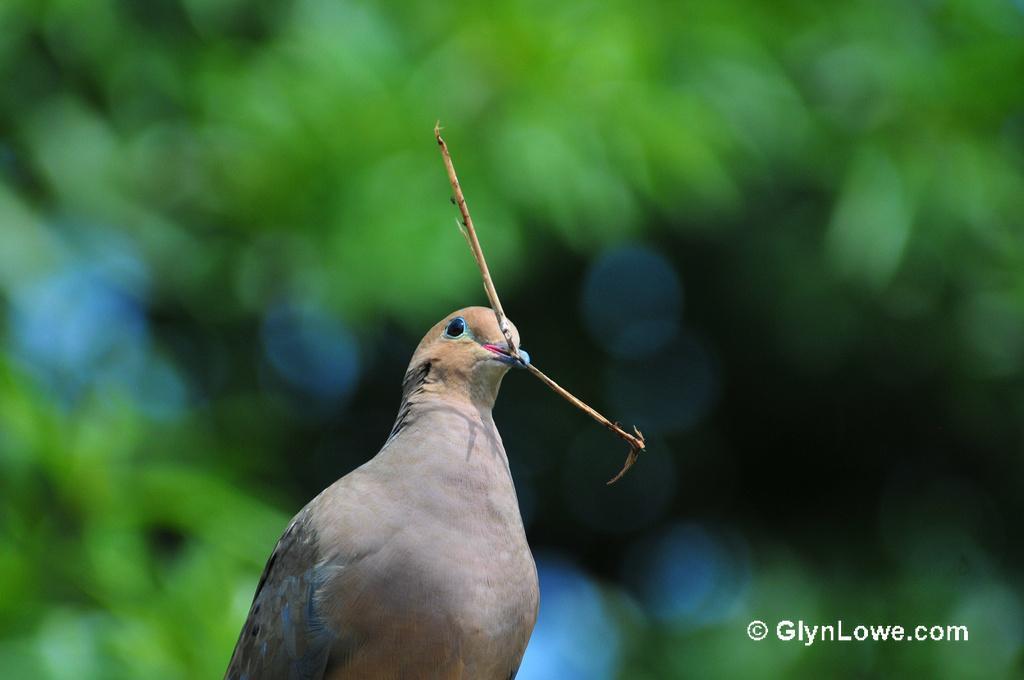How would you summarize this image in a sentence or two? In this image in the front there is a bird and the background is blurry and at the bottom right of the there is some text which is visible. 